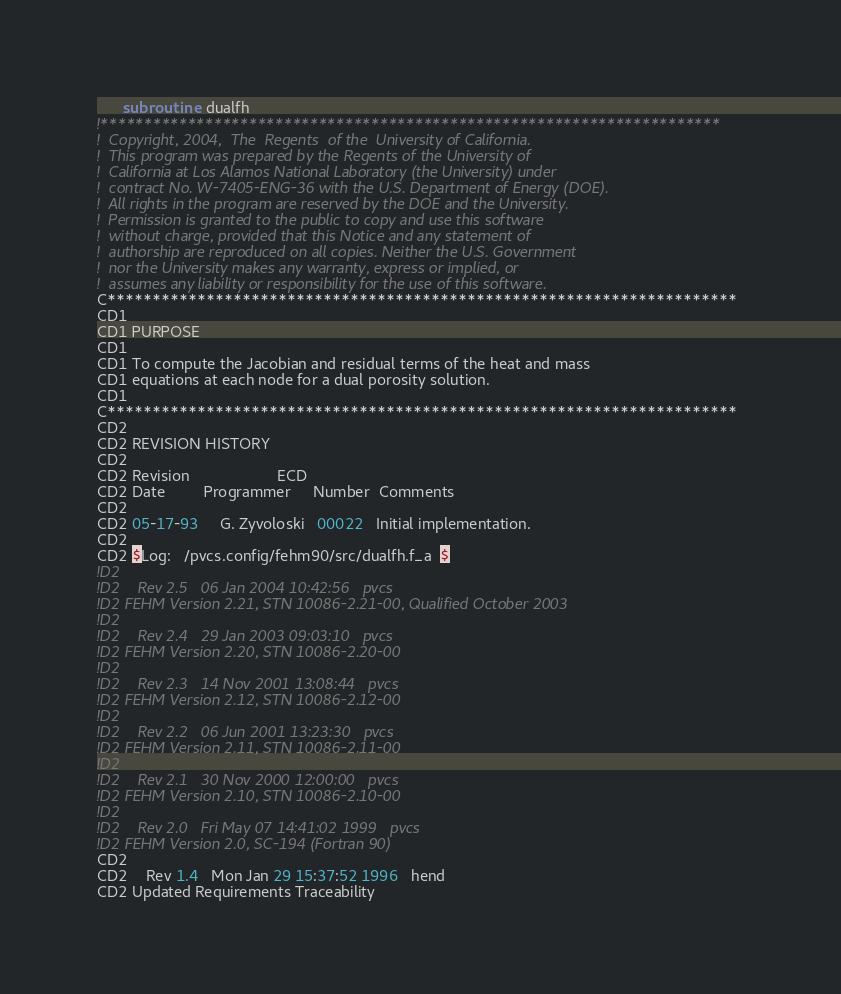<code> <loc_0><loc_0><loc_500><loc_500><_FORTRAN_>      subroutine  dualfh
!***********************************************************************
!  Copyright, 2004,  The  Regents  of the  University of California.
!  This program was prepared by the Regents of the University of 
!  California at Los Alamos National Laboratory (the University) under  
!  contract No. W-7405-ENG-36 with the U.S. Department of Energy (DOE). 
!  All rights in the program are reserved by the DOE and the University. 
!  Permission is granted to the public to copy and use this software 
!  without charge, provided that this Notice and any statement of 
!  authorship are reproduced on all copies. Neither the U.S. Government 
!  nor the University makes any warranty, express or implied, or 
!  assumes any liability or responsibility for the use of this software.
C**********************************************************************
CD1
CD1 PURPOSE
CD1
CD1 To compute the Jacobian and residual terms of the heat and mass
CD1 equations at each node for a dual porosity solution.
CD1
C**********************************************************************
CD2
CD2 REVISION HISTORY 
CD2
CD2 Revision                    ECD
CD2 Date         Programmer     Number  Comments
CD2
CD2 05-17-93     G. Zyvoloski   00022   Initial implementation.
CD2
CD2 $Log:   /pvcs.config/fehm90/src/dualfh.f_a  $
!D2 
!D2    Rev 2.5   06 Jan 2004 10:42:56   pvcs
!D2 FEHM Version 2.21, STN 10086-2.21-00, Qualified October 2003
!D2 
!D2    Rev 2.4   29 Jan 2003 09:03:10   pvcs
!D2 FEHM Version 2.20, STN 10086-2.20-00
!D2 
!D2    Rev 2.3   14 Nov 2001 13:08:44   pvcs
!D2 FEHM Version 2.12, STN 10086-2.12-00
!D2 
!D2    Rev 2.2   06 Jun 2001 13:23:30   pvcs
!D2 FEHM Version 2.11, STN 10086-2.11-00
!D2 
!D2    Rev 2.1   30 Nov 2000 12:00:00   pvcs
!D2 FEHM Version 2.10, STN 10086-2.10-00
!D2 
!D2    Rev 2.0   Fri May 07 14:41:02 1999   pvcs
!D2 FEHM Version 2.0, SC-194 (Fortran 90)
CD2 
CD2    Rev 1.4   Mon Jan 29 15:37:52 1996   hend
CD2 Updated Requirements Traceability</code> 